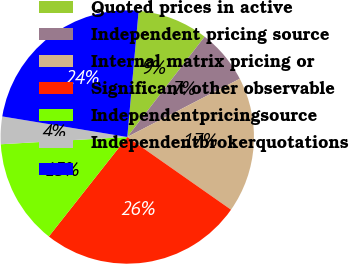<chart> <loc_0><loc_0><loc_500><loc_500><pie_chart><fcel>Quoted prices in active<fcel>Independent pricing source<fcel>Internal matrix pricing or<fcel>Significant other observable<fcel>Independentpricingsource<fcel>Independentbrokerquotations<fcel>Unnamed: 6<nl><fcel>9.02%<fcel>6.95%<fcel>17.33%<fcel>25.9%<fcel>13.46%<fcel>3.51%<fcel>23.83%<nl></chart> 